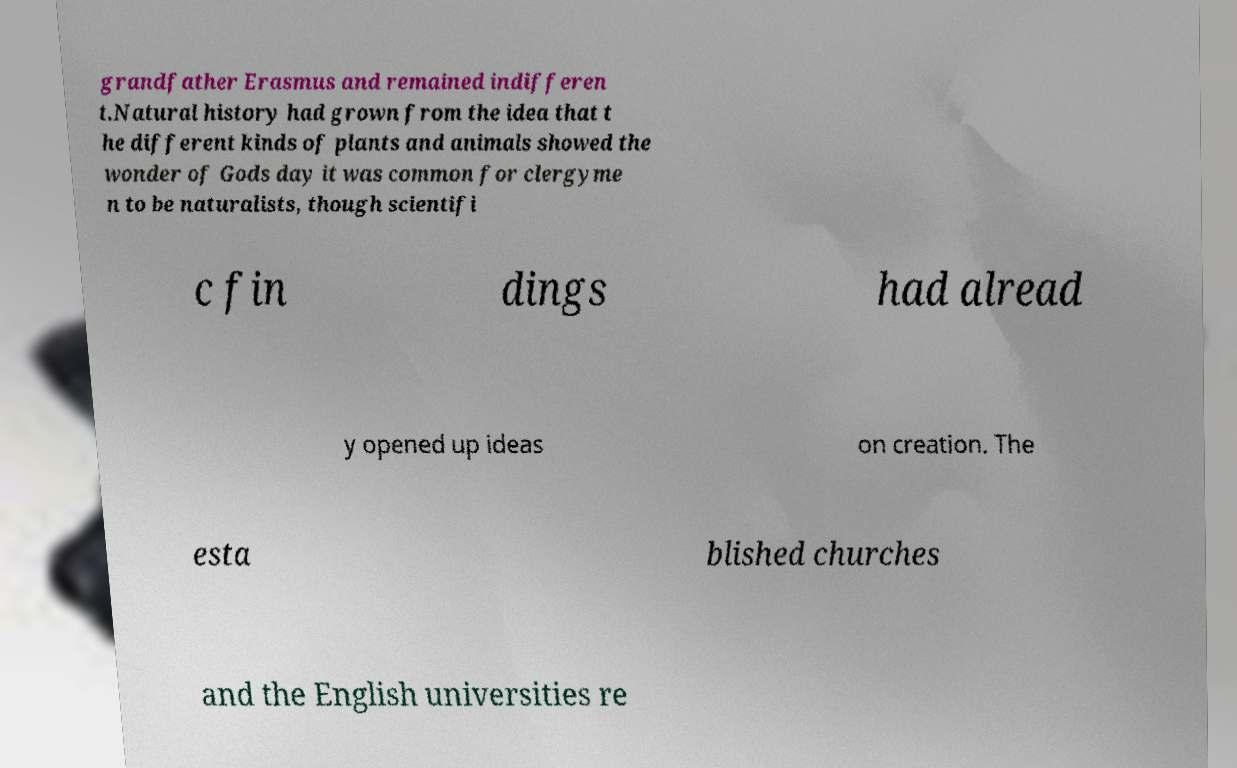Please identify and transcribe the text found in this image. grandfather Erasmus and remained indifferen t.Natural history had grown from the idea that t he different kinds of plants and animals showed the wonder of Gods day it was common for clergyme n to be naturalists, though scientifi c fin dings had alread y opened up ideas on creation. The esta blished churches and the English universities re 